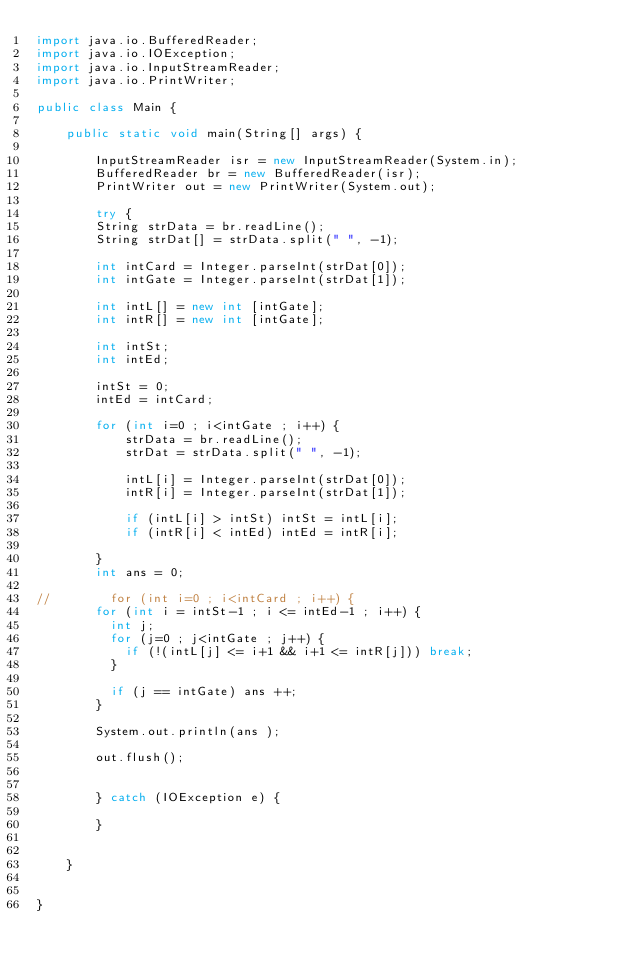<code> <loc_0><loc_0><loc_500><loc_500><_Java_>import java.io.BufferedReader;
import java.io.IOException;
import java.io.InputStreamReader;
import java.io.PrintWriter;

public class Main {

    public static void main(String[] args) {

        InputStreamReader isr = new InputStreamReader(System.in);
        BufferedReader br = new BufferedReader(isr);
        PrintWriter out = new PrintWriter(System.out);

        try {
    		String strData = br.readLine();
    		String strDat[] = strData.split(" ", -1);

    		int intCard = Integer.parseInt(strDat[0]);
    		int intGate = Integer.parseInt(strDat[1]);

    		int intL[] = new int [intGate];
    		int intR[] = new int [intGate];

    		int intSt;
    		int intEd;

    		intSt = 0;
    		intEd = intCard;

    		for (int i=0 ; i<intGate ; i++) {
        		strData = br.readLine();
        		strDat = strData.split(" ", -1);

        		intL[i] = Integer.parseInt(strDat[0]);
        		intR[i] = Integer.parseInt(strDat[1]);

        		if (intL[i] > intSt) intSt = intL[i];
        		if (intR[i] < intEd) intEd = intR[i];

    		}
    		int ans = 0;

//    		for (int i=0 ; i<intCard ; i++) {
    		for (int i = intSt-1 ; i <= intEd-1 ; i++) {
    			int j;
	    		for (j=0 ; j<intGate ; j++) {
	    			if (!(intL[j] <= i+1 && i+1 <= intR[j])) break;
	    		}

	    		if (j == intGate) ans ++;
    		}

    		System.out.println(ans );

    		out.flush();


        } catch (IOException e) {

        }


    }


}</code> 